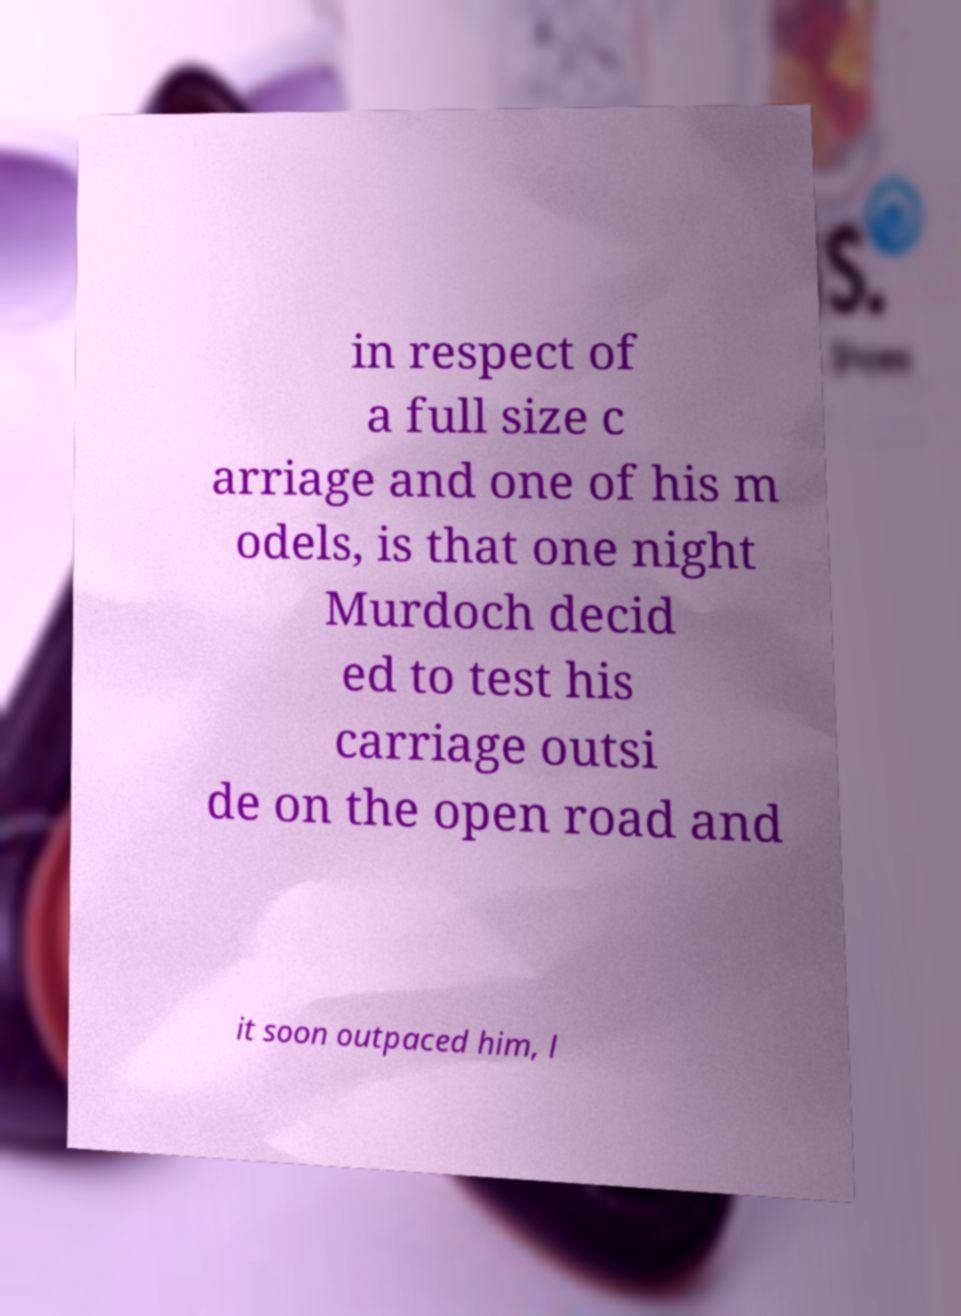Could you assist in decoding the text presented in this image and type it out clearly? in respect of a full size c arriage and one of his m odels, is that one night Murdoch decid ed to test his carriage outsi de on the open road and it soon outpaced him, l 